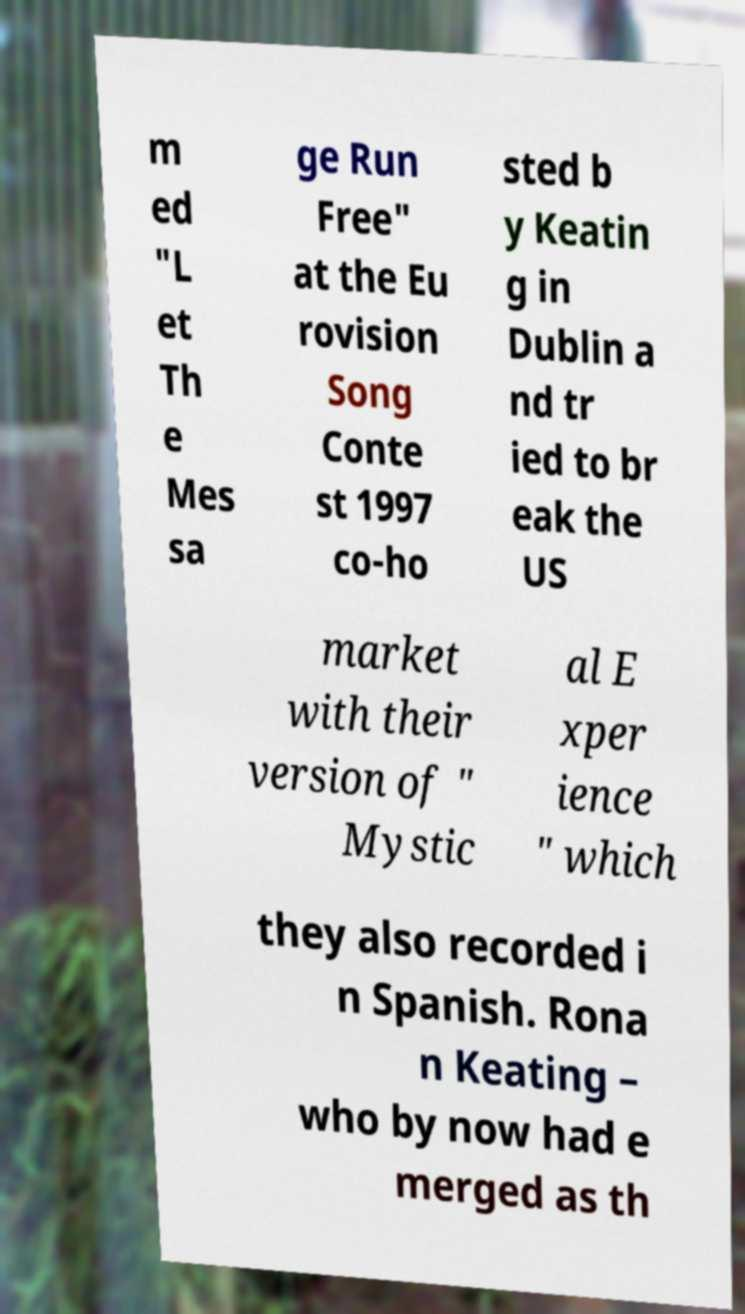Please identify and transcribe the text found in this image. m ed "L et Th e Mes sa ge Run Free" at the Eu rovision Song Conte st 1997 co-ho sted b y Keatin g in Dublin a nd tr ied to br eak the US market with their version of " Mystic al E xper ience " which they also recorded i n Spanish. Rona n Keating – who by now had e merged as th 